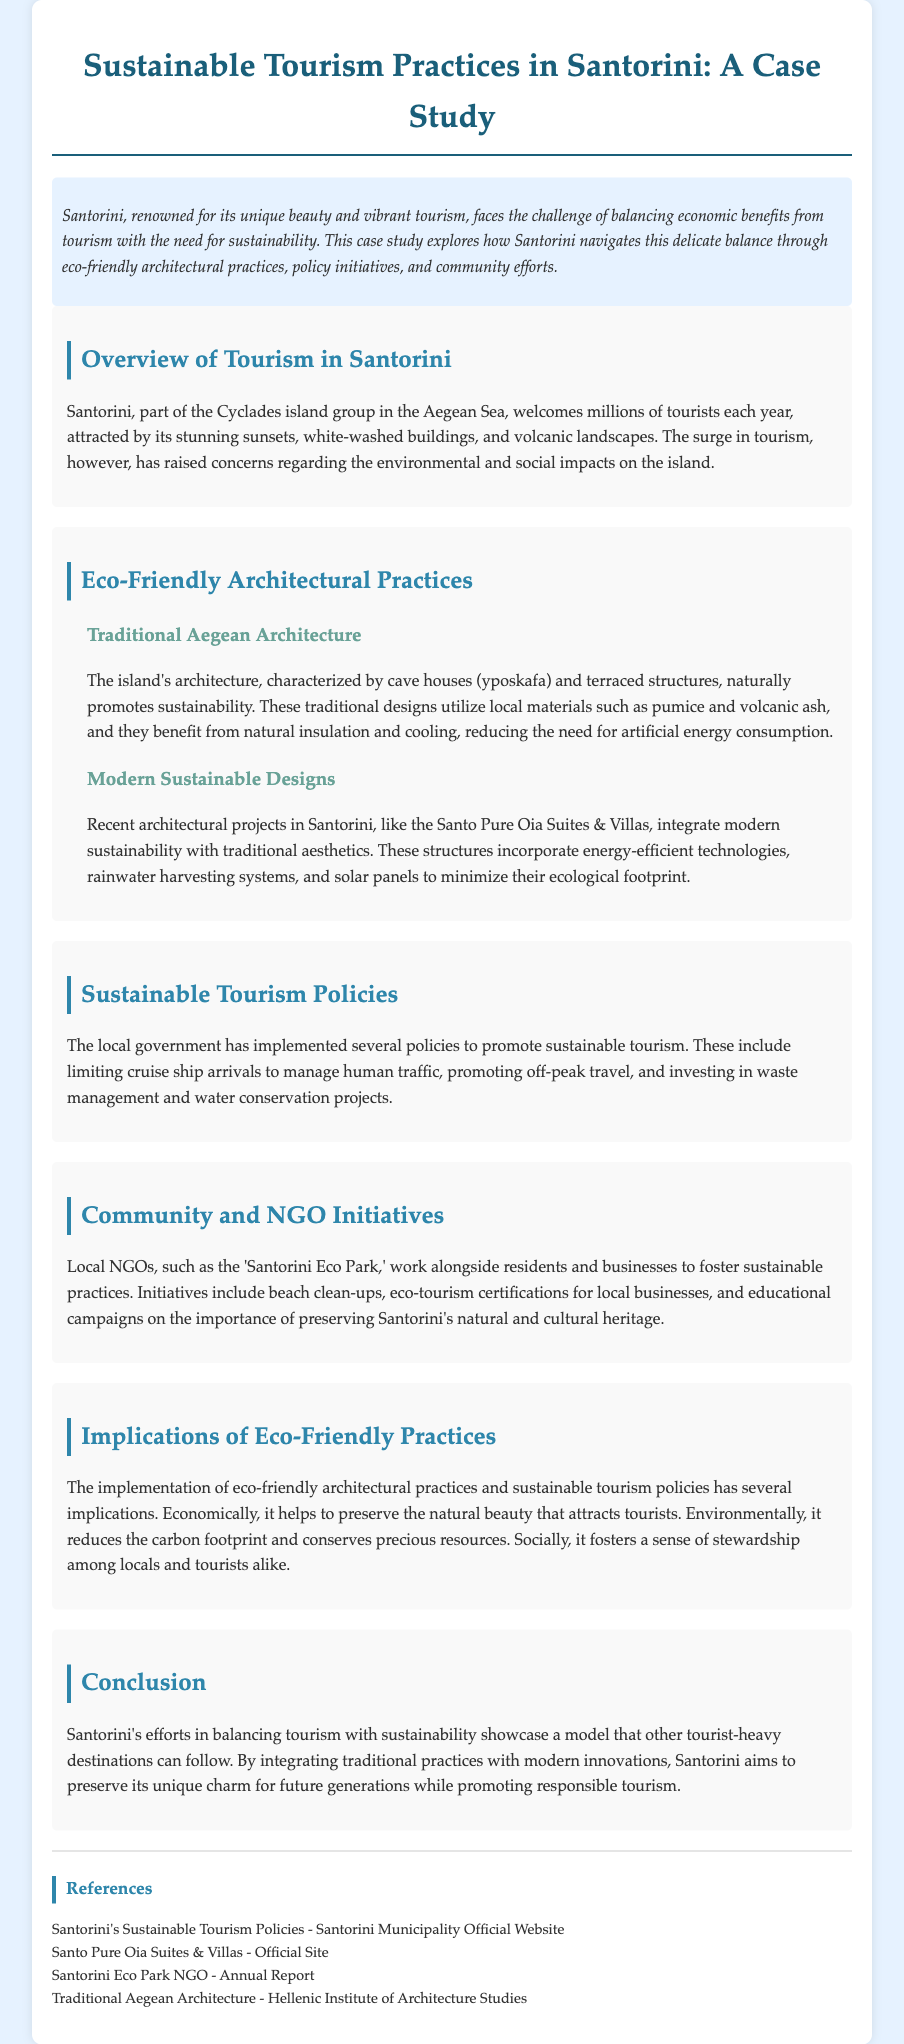what is the primary challenge Santorini faces regarding tourism? The primary challenge is balancing economic benefits from tourism with the need for sustainability.
Answer: balancing economic benefits from tourism with the need for sustainability what materials are traditionally used in Aegean architecture? Traditional Aegean architecture utilizes local materials such as pumice and volcanic ash.
Answer: pumice and volcanic ash what sustainable feature does the Santo Pure Oia Suites & Villas incorporate? Santo Pure Oia Suites & Villas incorporates solar panels as part of its sustainable design.
Answer: solar panels how many tourists does Santorini welcome each year? The document states that Santorini welcomes millions of tourists each year.
Answer: millions which local NGO supports sustainable practices in Santorini? The NGO mentioned that supports sustainable practices is the 'Santorini Eco Park.'
Answer: Santorini Eco Park why is limiting cruise ship arrivals beneficial for Santorini? Limiting cruise ship arrivals helps manage human traffic, reducing environmental impact.
Answer: manage human traffic what implication do eco-friendly practices have economically? Eco-friendly practices help preserve the natural beauty that attracts tourists.
Answer: preserve the natural beauty what type of architecture is characterized by cave houses? Traditional Aegean architecture is characterized by cave houses (yposkafa).
Answer: Traditional Aegean architecture what does the local government invest in to promote sustainability? The local government invests in waste management and water conservation projects.
Answer: waste management and water conservation projects 